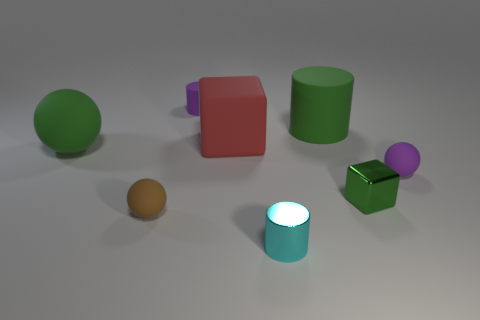Add 2 rubber things. How many objects exist? 10 Subtract all spheres. How many objects are left? 5 Subtract all large green matte objects. Subtract all large objects. How many objects are left? 3 Add 2 matte cylinders. How many matte cylinders are left? 4 Add 7 green rubber blocks. How many green rubber blocks exist? 7 Subtract 0 gray cubes. How many objects are left? 8 